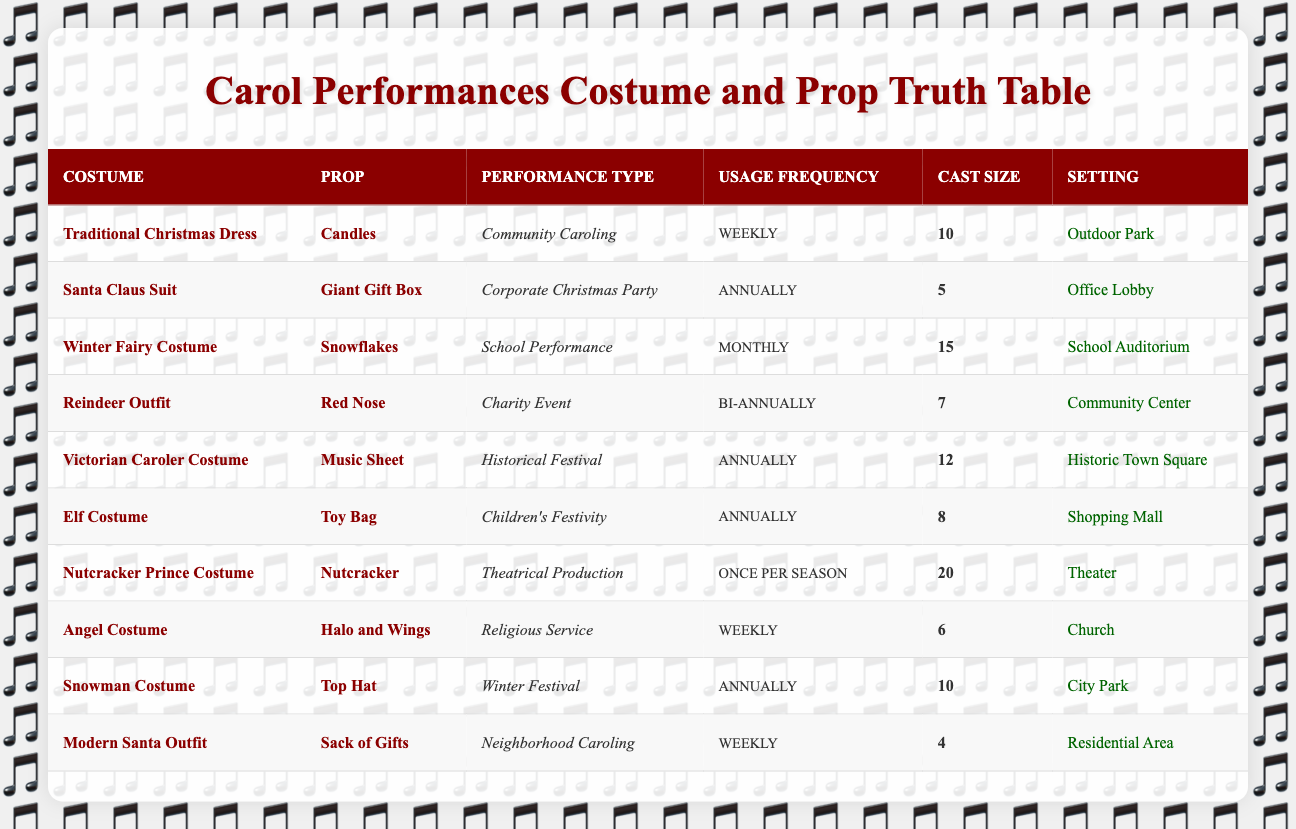What is the usage frequency of the Reindeer Outfit? By looking at the "Usage Frequency" column for the Reindeer Outfit, it is listed as "Bi-annually."
Answer: Bi-annually How many performances feature weekly usage frequency? Scanning the table, we find that there are three costumes (Traditional Christmas Dress, Angel Costume, Modern Santa Outfit) with a weekly usage frequency.
Answer: 3 Which performance type has the largest cast size? The "Theatrical Production" with the Nutcracker Prince Costume has the largest cast size listed, which is 20 members.
Answer: Theatrical Production Is the Elf Costume used in a charity event? Checking the performance type for the Elf Costume, it is used for "Children's Festivity," and not for a charity event. Therefore, the answer is no.
Answer: No What is the total cast size for all performances that occur annually? The cast sizes for annually performing types are: Corporate Christmas Party (5), Historical Festival (12), Elf Costume (8), Snowman Costume (10). Summing these gives: 5 + 12 + 8 + 10 = 35.
Answer: 35 How many different performance types are associated with weekly usage of costumes? The table shows three performance types with weekly costume usage: Community Caroling, Religious Service, and Neighborhood Caroling, totaling three distinct types.
Answer: 3 Does the Victorian Caroler Costume require any props for its performance? Yes, it is paired with the Music Sheet prop, as can be seen directly in the table.
Answer: Yes What is the average cast size for the performances? Adding up all the cast sizes (10 + 5 + 15 + 7 + 12 + 8 + 20 + 6 + 10 + 4) gives a total of 97. As there are 10 performances, 97 divided by 10 equals an average of 9.7.
Answer: 9.7 